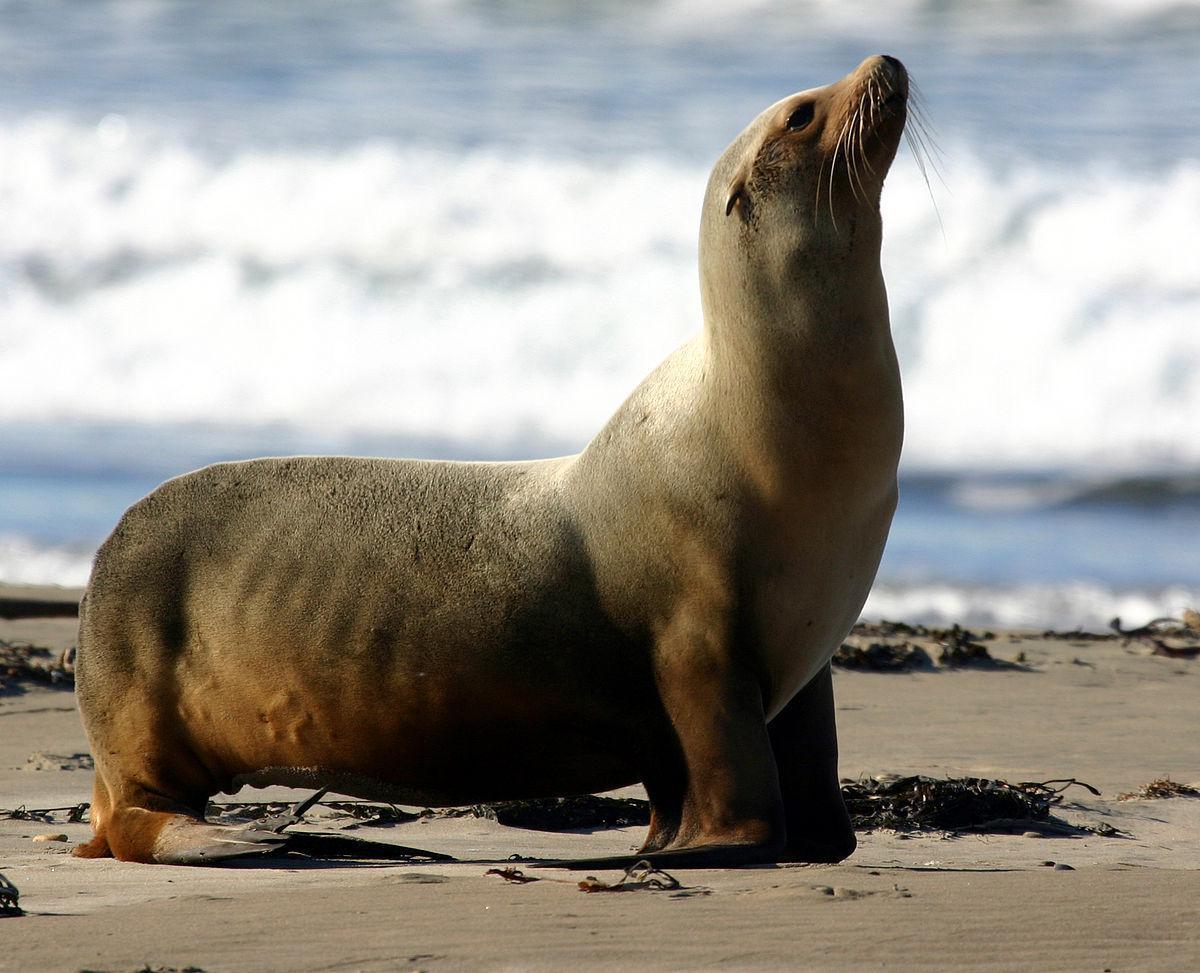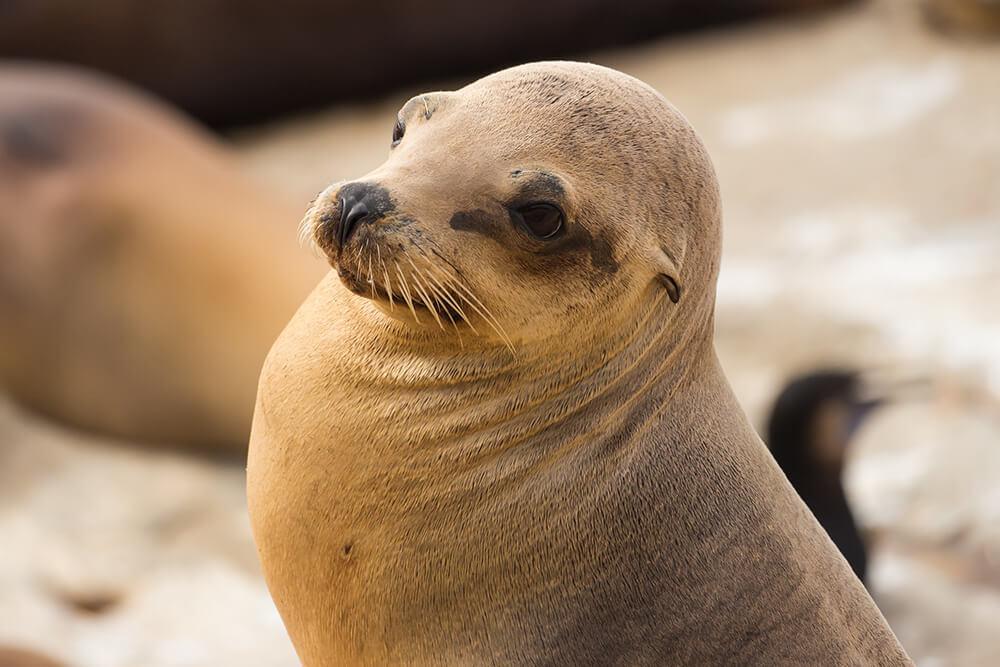The first image is the image on the left, the second image is the image on the right. Examine the images to the left and right. Is the description "There are two sea lions facing left." accurate? Answer yes or no. No. The first image is the image on the left, the second image is the image on the right. Considering the images on both sides, is "Both of the seals are looking to the left of the image." valid? Answer yes or no. No. 